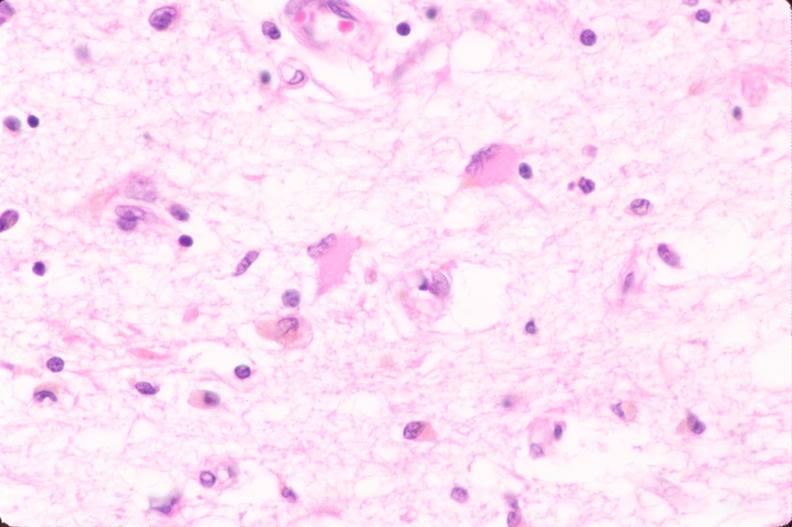where is this?
Answer the question using a single word or phrase. Lung 